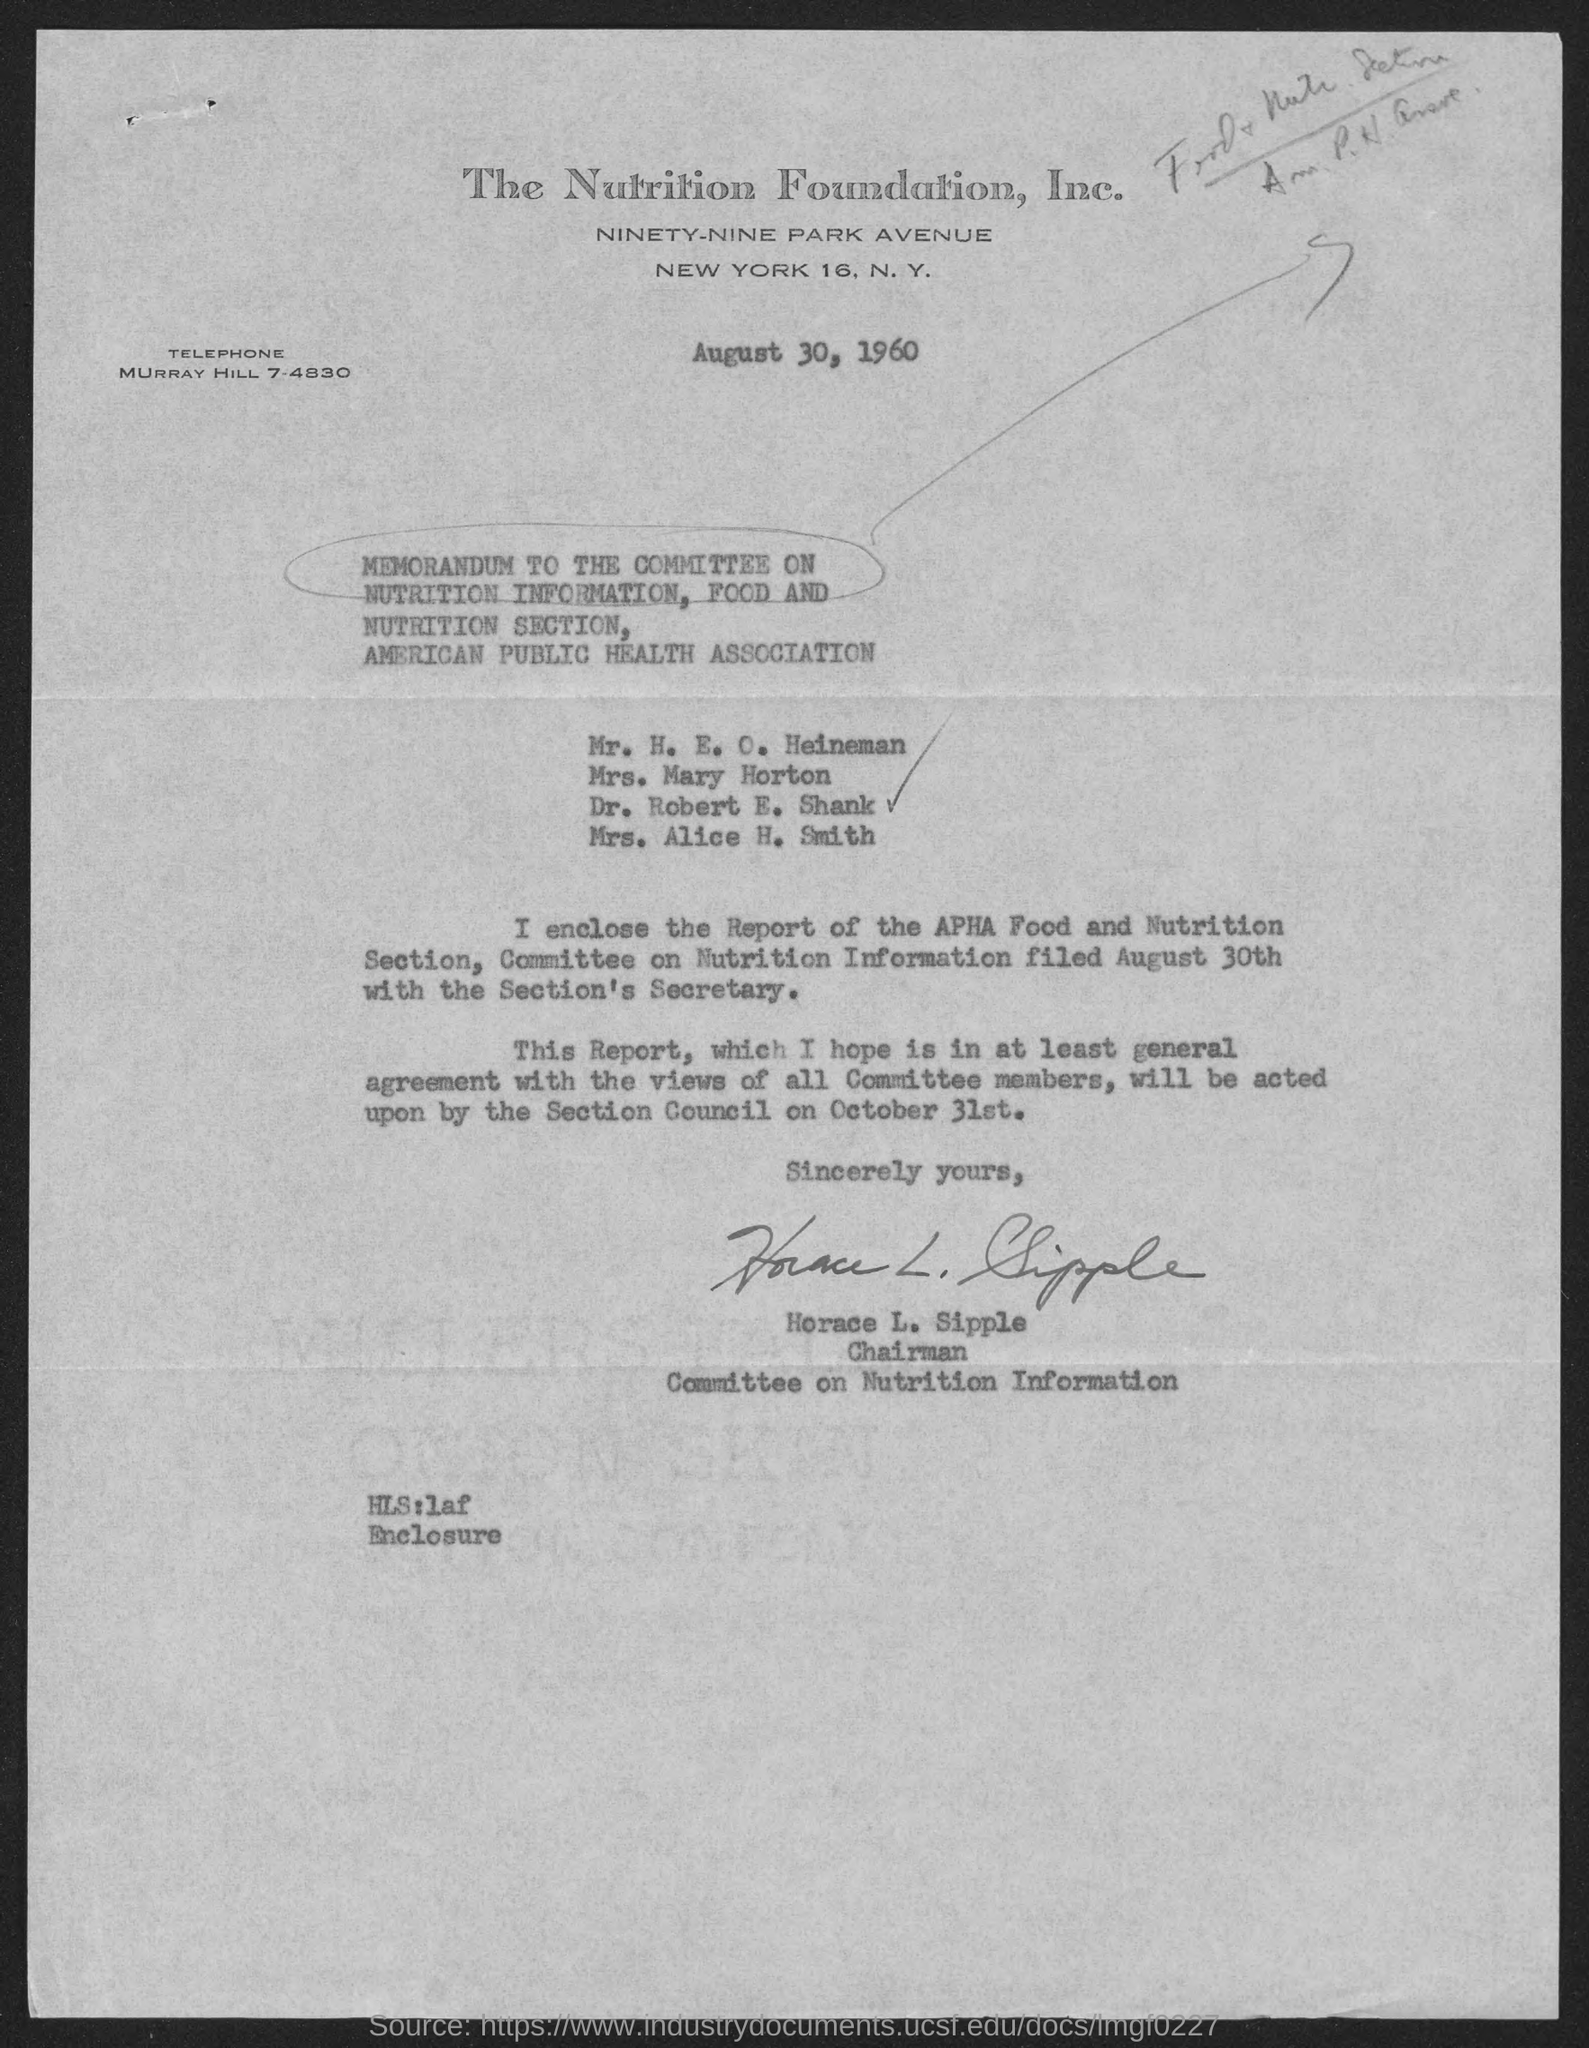List a handful of essential elements in this visual. Horace L. Sipple is the Chairman. The letter is dated August 30, 1960. 